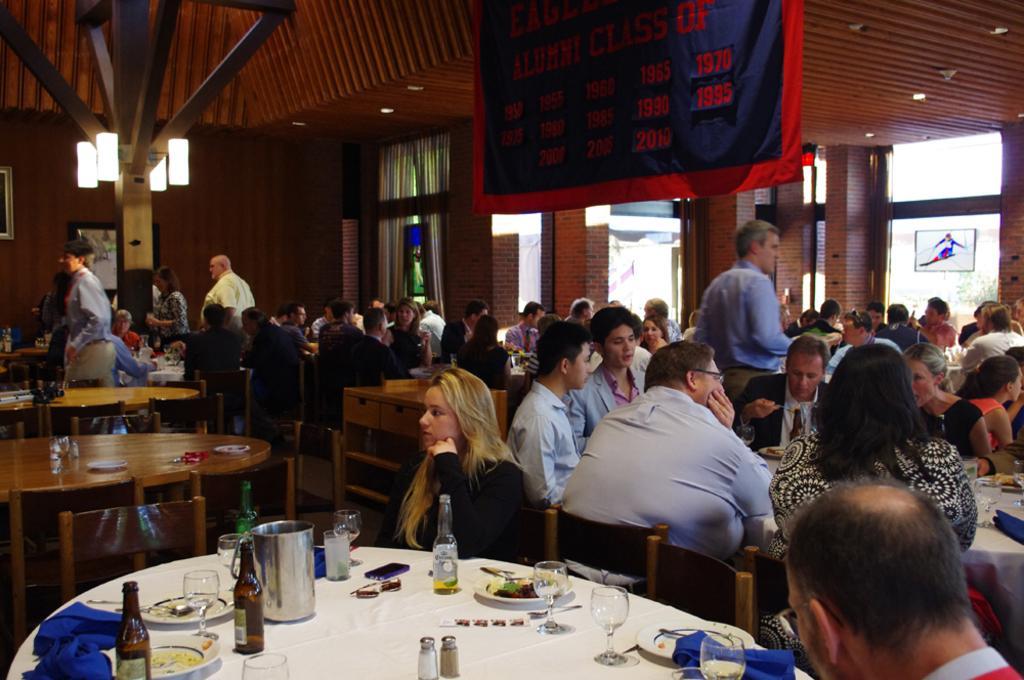How would you summarize this image in a sentence or two? In this image there are group of people sitting on a chair and some people are standing the table is covered with a white colour cloth on this table we can see a bottles,plates and some food on this plate we can see a mobile phone and this woman is leaning on the table and seems like she is thinking something behind this woman there is a man leaning on the table and is looking opposite to the woman or man is eating on the top we can see a banner with some numbers like 1970,2010. In the background we can see red colour bricks,wall and a window. 